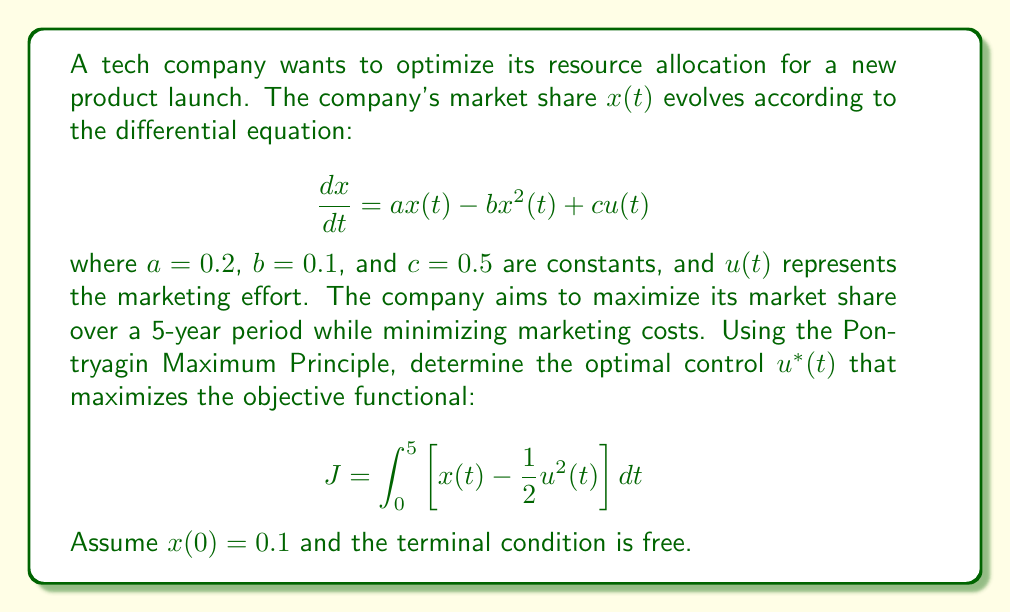Help me with this question. To solve this optimal control problem, we'll use the Pontryagin Maximum Principle:

1. Define the Hamiltonian:
   $$H = x - \frac{1}{2}u^2 + \lambda(ax - bx^2 + cu)$$

2. Derive the costate equation:
   $$\frac{d\lambda}{dt} = -\frac{\partial H}{\partial x} = -1 - \lambda(a - 2bx)$$

3. Determine the optimal control by maximizing H with respect to u:
   $$\frac{\partial H}{\partial u} = -u + \lambda c = 0$$
   $$u^*(t) = \lambda(t)c = 0.5\lambda(t)$$

4. Substitute the optimal control into the state and costate equations:
   $$\frac{dx}{dt} = 0.2x - 0.1x^2 + 0.25\lambda$$
   $$\frac{d\lambda}{dt} = -1 - \lambda(0.2 - 0.2x)$$

5. Solve this two-point boundary value problem numerically, given:
   - Initial condition: $x(0) = 0.1$
   - Terminal condition: $\lambda(5) = 0$ (transversality condition for free endpoint)

6. The solution will give us $x(t)$ and $\lambda(t)$ for $t \in [0,5]$

7. The optimal control is then $u^*(t) = 0.5\lambda(t)$

Note: The exact analytical solution is complex, so numerical methods are typically used in practice.
Answer: $u^*(t) = 0.5\lambda(t)$, where $\lambda(t)$ is obtained by solving the two-point boundary value problem numerically. 